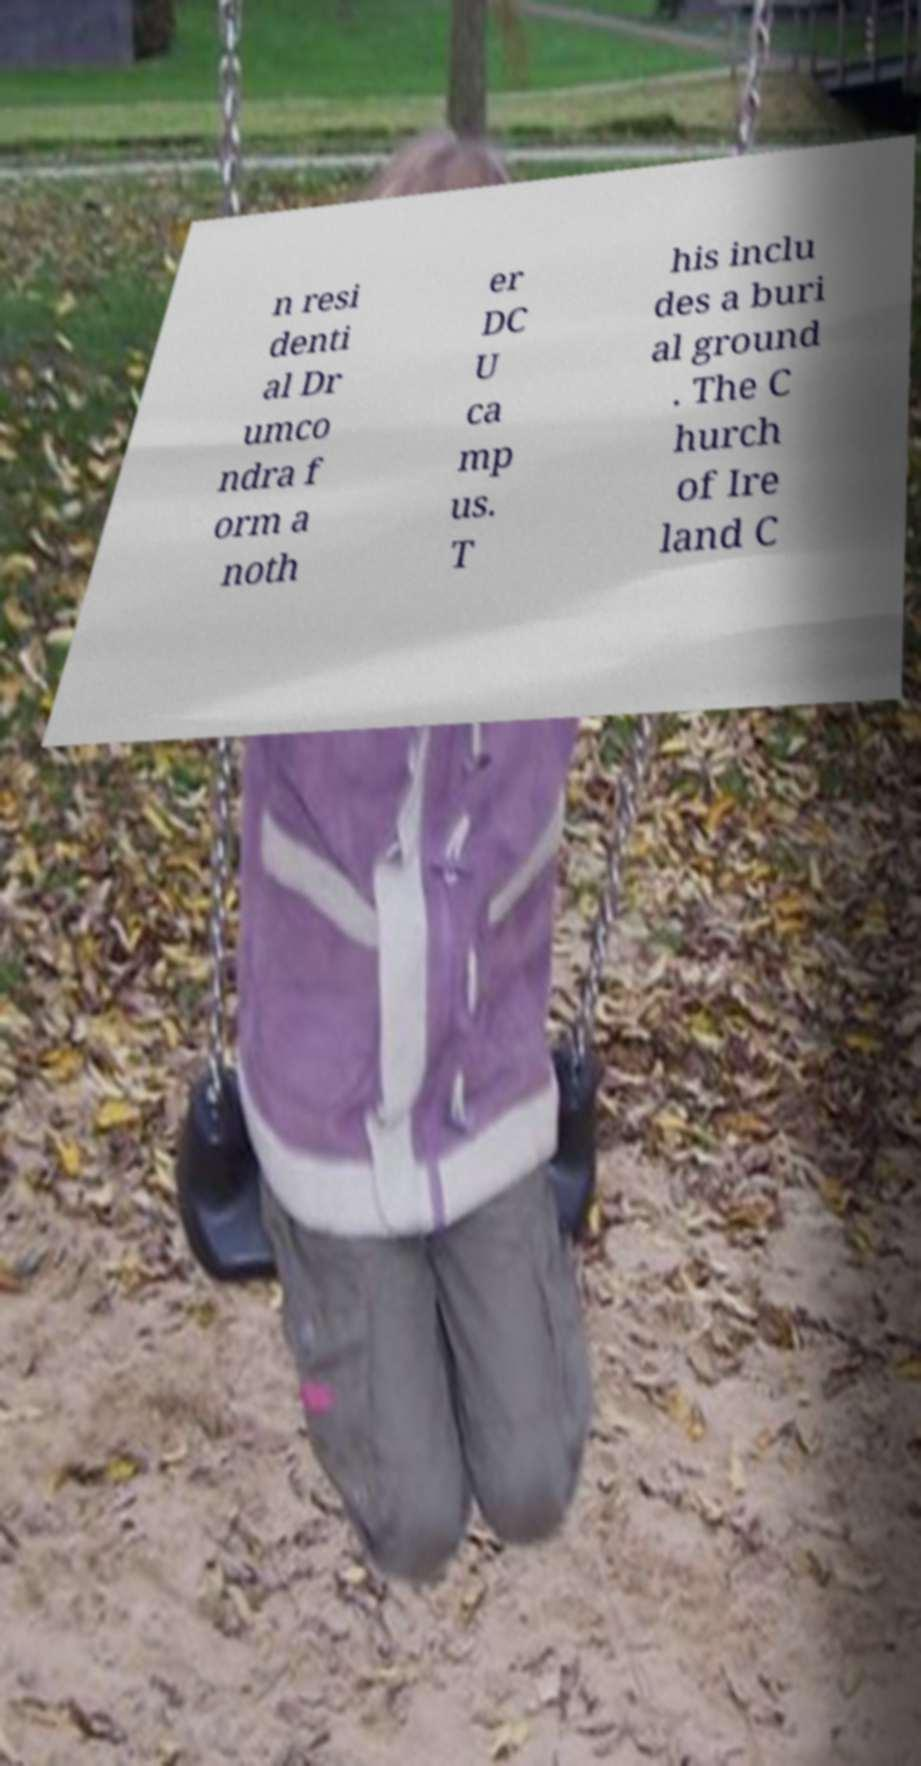Please read and relay the text visible in this image. What does it say? n resi denti al Dr umco ndra f orm a noth er DC U ca mp us. T his inclu des a buri al ground . The C hurch of Ire land C 